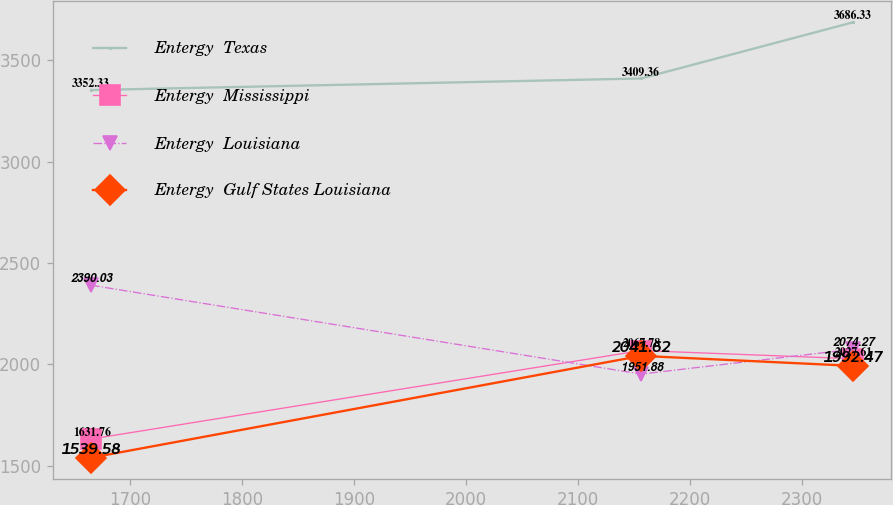Convert chart. <chart><loc_0><loc_0><loc_500><loc_500><line_chart><ecel><fcel>Entergy  Texas<fcel>Entergy  Mississippi<fcel>Entergy  Louisiana<fcel>Entergy  Gulf States Louisiana<nl><fcel>1665.11<fcel>3352.33<fcel>1631.76<fcel>2390.03<fcel>1539.58<nl><fcel>2156.1<fcel>3409.36<fcel>2067.78<fcel>1951.88<fcel>2041.62<nl><fcel>2345.23<fcel>3686.33<fcel>2027.61<fcel>2074.27<fcel>1992.47<nl></chart> 